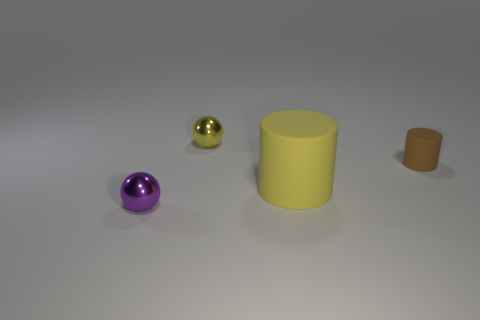Add 4 tiny yellow metallic things. How many objects exist? 8 Subtract all brown cylinders. How many cylinders are left? 1 Subtract 2 balls. How many balls are left? 0 Add 3 cylinders. How many cylinders exist? 5 Subtract 0 red blocks. How many objects are left? 4 Subtract all gray cylinders. Subtract all purple balls. How many cylinders are left? 2 Subtract all yellow blocks. How many yellow cylinders are left? 1 Subtract all tiny yellow shiny balls. Subtract all rubber things. How many objects are left? 1 Add 1 tiny purple metallic spheres. How many tiny purple metallic spheres are left? 2 